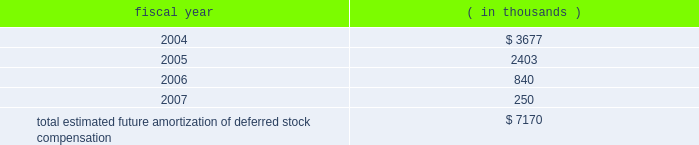The table presents the estimated future amortization of deferred stock compensation reported in both cost of revenue and operating expenses : fiscal year ( in thousands ) .
Impairment of intangible assets .
In fiscal 2002 , we recognized an aggregate impairment charge of $ 3.8 million to reduce the amount of certain intangible assets associated with prior acquisitions to their estimated fair value .
Approximately $ 3.7 million and $ 0.1 million are included in integration expense and amortization of intangible assets , respectively , on the consolidated statement of operations .
The impairment charge is primarily attributable to certain technology acquired from and goodwill related to the acquisition of stanza , inc .
( stanza ) in 1999 .
During fiscal 2002 , we determined that we would not allocate future resources to assist in the market growth of this technology as products acquired in the merger with avant! provided customers with superior capabilities .
As a result , we do not anticipate any future sales of the stanza product .
In fiscal 2001 , we recognized an aggregate impairment charge of $ 2.2 million to reduce the amount of certain intangible assets associated with prior acquisitions to their estimated fair value .
Approximately $ 1.8 million and $ 0.4 million are included in cost of revenues and amortization of intangible assets , respectively , on the consolidated statement of operations .
The impairment charge is attributable to certain technology acquired from and goodwill related to the acquisition of eagle design automation , inc .
( eagle ) in 1997 .
During fiscal 2001 , we determined that we would not allocate future resources to assist in the market growth of this technology .
As a result , we do not anticipate any future sales of the eagle product .
There were no impairment charges during fiscal 2003 .
Other ( expense ) income , net .
Other income , net was $ 24.1 million in fiscal 2003 and consisted primarily of ( i ) realized gain on investments of $ 20.7 million ; ( ii ) rental income of $ 6.3 million ; ( iii ) interest income of $ 5.2 million ; ( iv ) impairment charges related to certain assets in our venture portfolio of ( $ 4.5 ) million ; ( vii ) foundation contributions of ( $ 2.1 ) million ; and ( viii ) interest expense of ( $ 1.6 ) million .
Other ( expense ) , net of other income was ( $ 208.6 ) million in fiscal 2002 and consisted primarily of ( i ) ( $ 240.8 ) million expense due to the settlement of the cadence design systems , inc .
( cadence ) litigation ; ( ii ) ( $ 11.3 ) million in impairment charges related to certain assets in our venture portfolio ; ( iii ) realized gains on investments of $ 22.7 million ; ( iv ) a gain of $ 3.1 million for the termination fee on the ikos systems , inc .
( ikos ) merger agreement ; ( v ) rental income of $ 10.0 million ; ( vi ) interest income of $ 8.3 million ; and ( vii ) and other miscellaneous expenses including amortization of premium forwards and foreign exchange gains and losses recognized during the fiscal year of ( $ 0.6 ) million .
Other income , net was $ 83.8 million in fiscal 2001 and consisted primarily of ( i ) a gain of $ 10.6 million on the sale of our silicon libraries business to artisan components , inc. ; ( ii ) ( $ 5.8 ) million in impairment charges related to certain assets in our venture portfolio ; ( iii ) realized gains on investments of $ 55.3 million ; ( iv ) rental income of $ 8.6 million ; ( v ) interest income of $ 12.8 million ; and ( vi ) other miscellaneous income including amortization of premium forwards and foreign exchange gains and losses recognized during the fiscal year of $ 2.3 million .
Termination of agreement to acquire ikos systems , inc .
On july 2 , 2001 , we entered into an agreement and plan of merger and reorganization ( the ikos merger agreement ) with ikos systems , inc .
The ikos merger agreement provided for the acquisition of all outstanding shares of ikos common stock by synopsys. .
What is the percentage of 2006's estimated future amortization of deferred stock compensation among the total? 
Rationale: it is the 2006's value divided by the total amount , then turned into a percentage .
Computations: (840 / 7170)
Answer: 0.11715. 